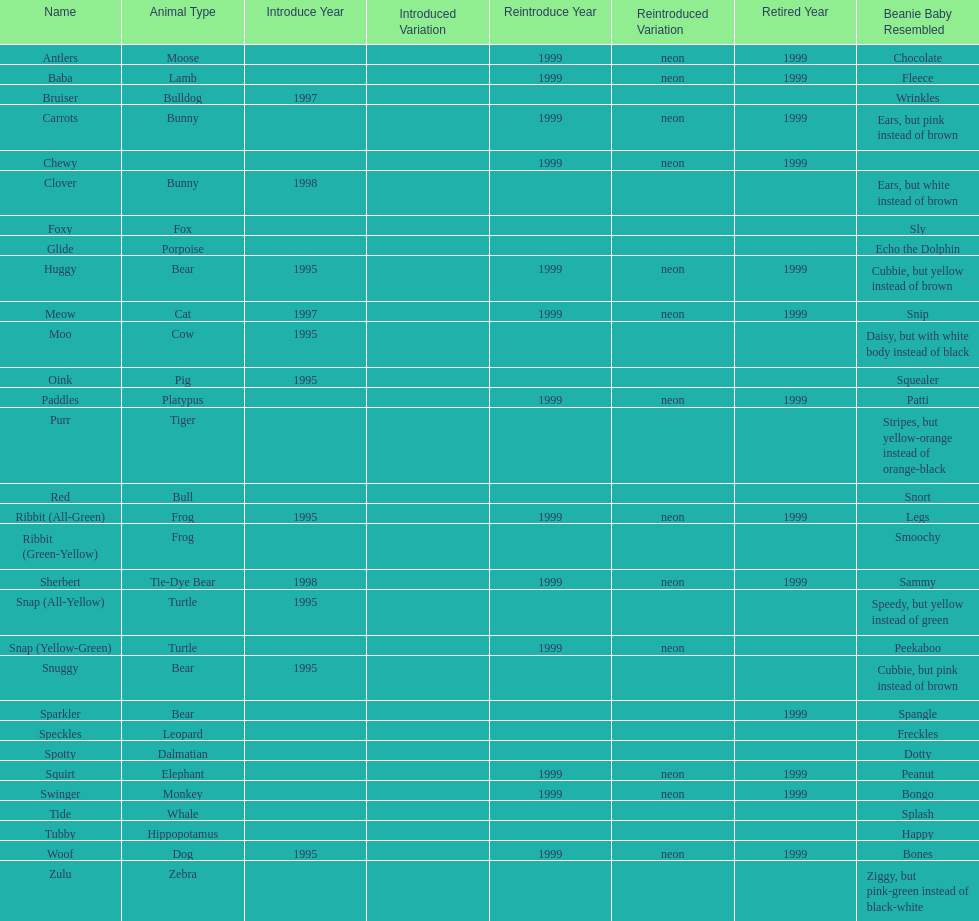Which is the only pillow pal without a listed animal type? Chewy. 